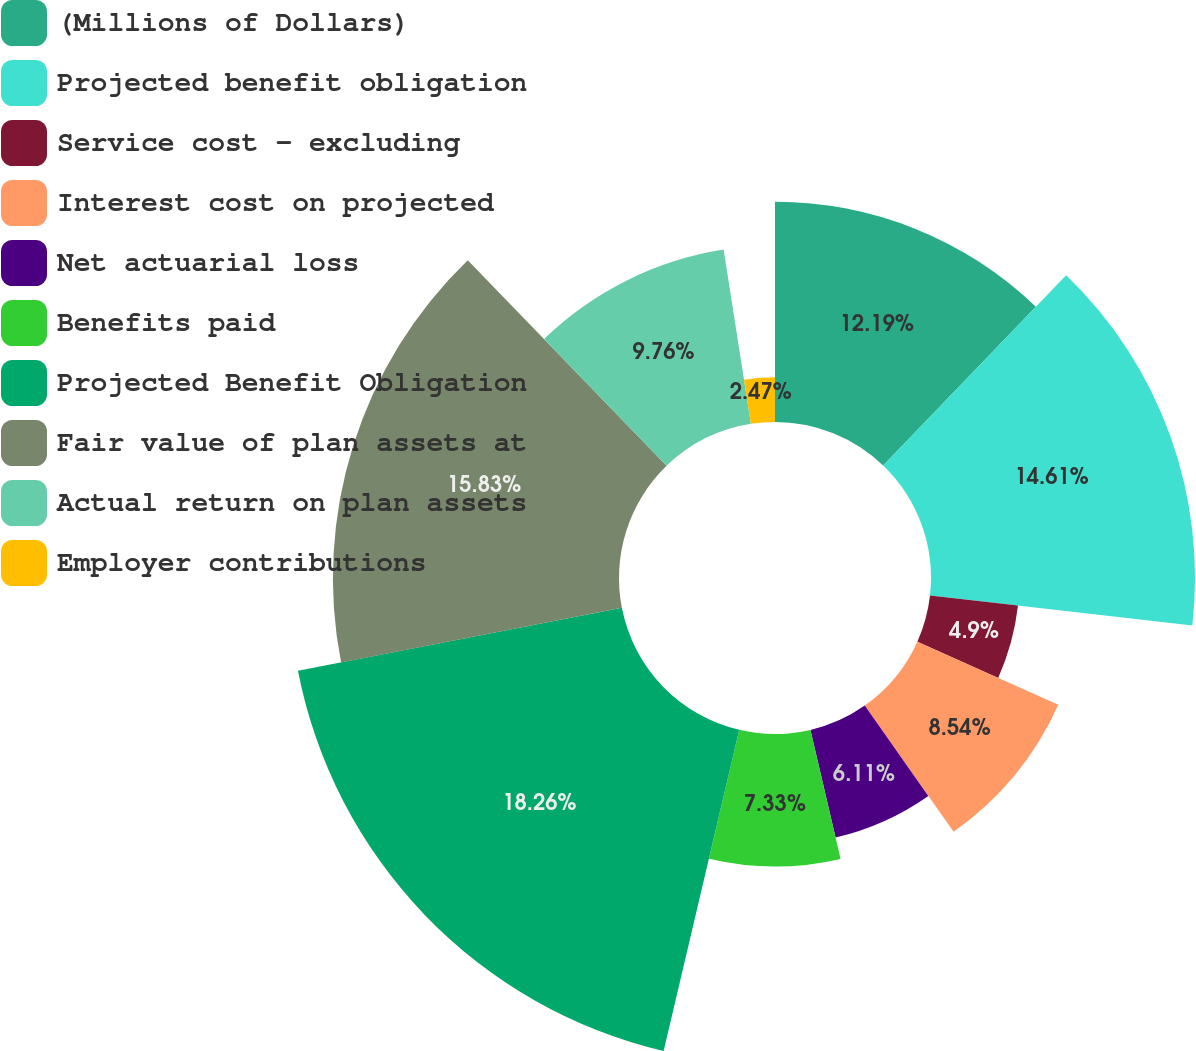Convert chart. <chart><loc_0><loc_0><loc_500><loc_500><pie_chart><fcel>(Millions of Dollars)<fcel>Projected benefit obligation<fcel>Service cost - excluding<fcel>Interest cost on projected<fcel>Net actuarial loss<fcel>Benefits paid<fcel>Projected Benefit Obligation<fcel>Fair value of plan assets at<fcel>Actual return on plan assets<fcel>Employer contributions<nl><fcel>12.19%<fcel>14.61%<fcel>4.9%<fcel>8.54%<fcel>6.11%<fcel>7.33%<fcel>18.26%<fcel>15.83%<fcel>9.76%<fcel>2.47%<nl></chart> 